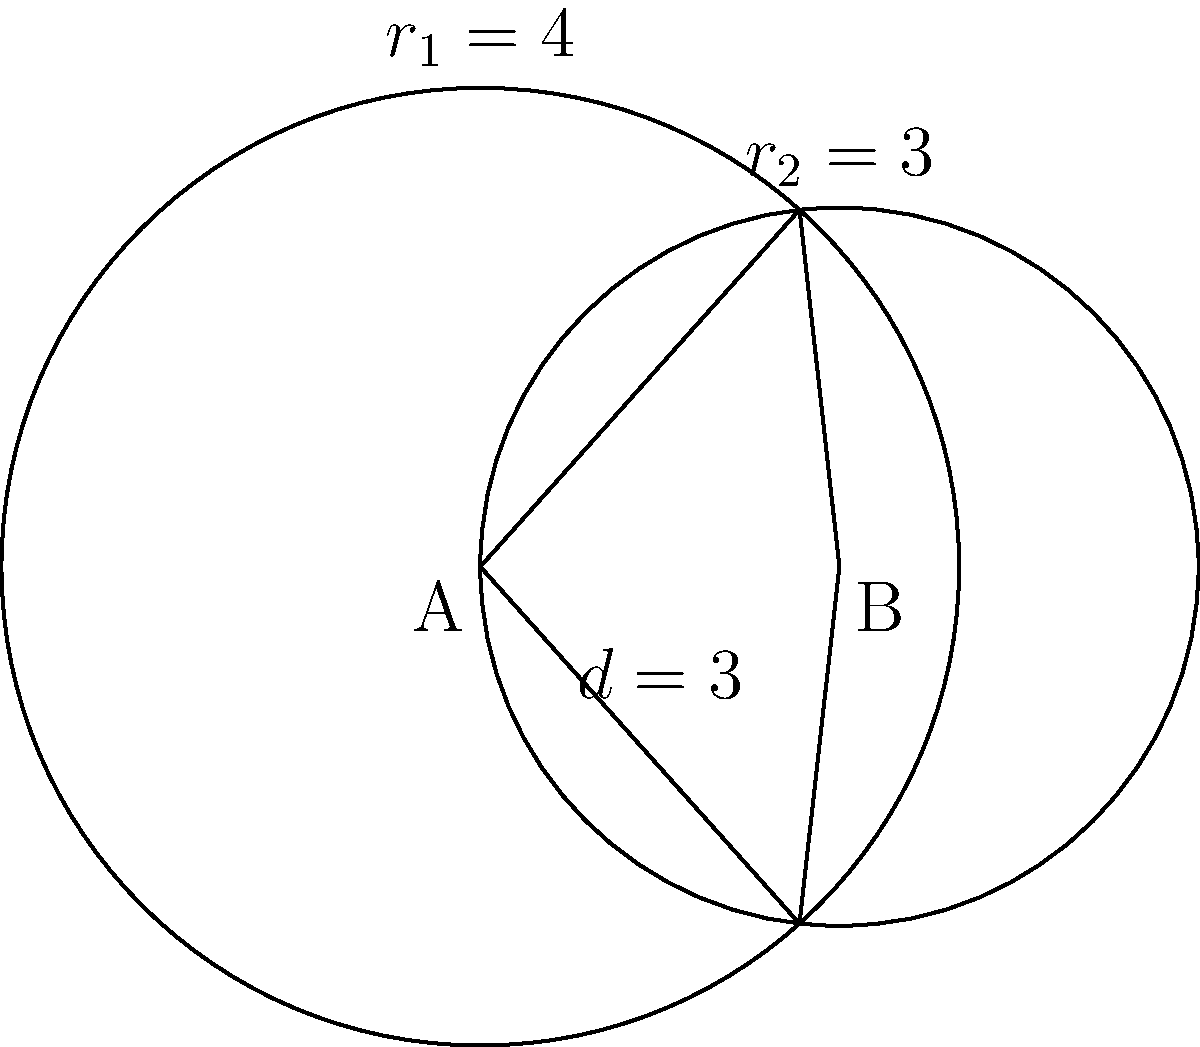For the upcoming Brian Helgeland film festival, you're designing a poster with overlapping circular spotlights. The centers of the spotlights are 3 units apart, with radii of 4 and 3 units respectively. What is the area of the region where the spotlights overlap? To find the area of overlap between two circles, we can use the formula:

$$A = r_1^2 \arccos(\frac{d^2 + r_1^2 - r_2^2}{2dr_1}) + r_2^2 \arccos(\frac{d^2 + r_2^2 - r_1^2}{2dr_2}) - \frac{1}{2}\sqrt{(-d+r_1+r_2)(d+r_1-r_2)(d-r_1+r_2)(d+r_1+r_2)}$$

Where:
$r_1 = 4$ (radius of the larger circle)
$r_2 = 3$ (radius of the smaller circle)
$d = 3$ (distance between centers)

Step 1: Calculate the first term
$$r_1^2 \arccos(\frac{d^2 + r_1^2 - r_2^2}{2dr_1}) = 16 \arccos(\frac{9 + 16 - 9}{2 \cdot 3 \cdot 4}) = 16 \arccos(\frac{4}{6})$$

Step 2: Calculate the second term
$$r_2^2 \arccos(\frac{d^2 + r_2^2 - r_1^2}{2dr_2}) = 9 \arccos(\frac{9 + 9 - 16}{2 \cdot 3 \cdot 3}) = 9 \arccos(\frac{1}{6})$$

Step 3: Calculate the third term
$$\frac{1}{2}\sqrt{(-d+r_1+r_2)(d+r_1-r_2)(d-r_1+r_2)(d+r_1+r_2)} = \frac{1}{2}\sqrt{(4)(4)(0)(10)} = 0$$

Step 4: Sum up the terms
$$A = 16 \arccos(\frac{2}{3}) + 9 \arccos(\frac{1}{6}) - 0$$

Step 5: Evaluate using a calculator
$$A \approx 16 \cdot 0.8411 + 9 \cdot 1.5708 - 0 \approx 27.7548$$

Therefore, the area of overlap is approximately 27.7548 square units.
Answer: 27.7548 square units 